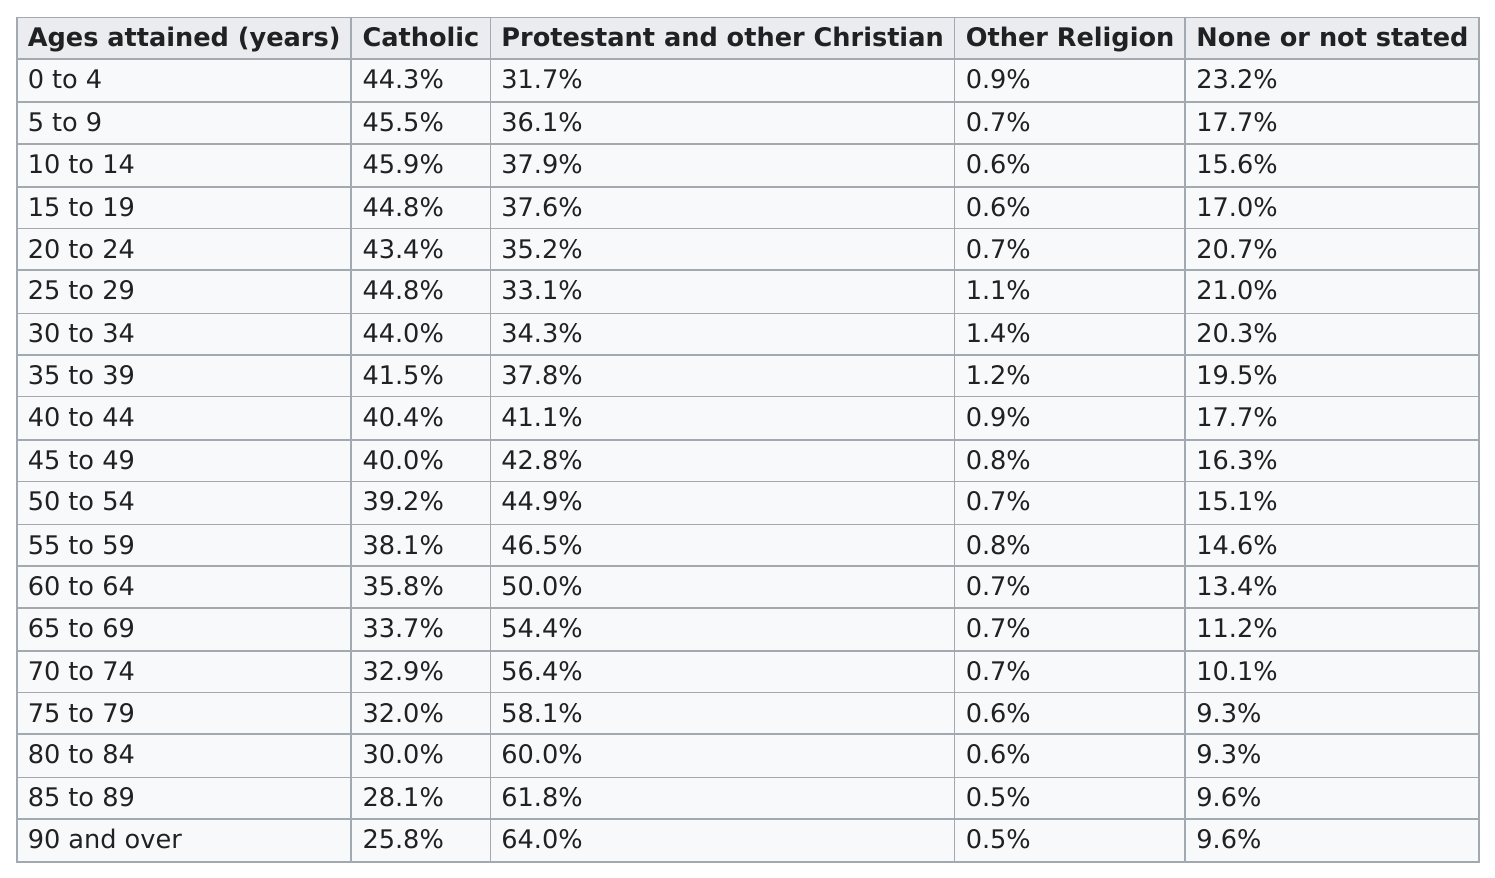List a handful of essential elements in this visual. The age range of 90 and over had the highest number of protestants and other Christians. According to data, the age range of 30 to 34 features the largest percentage of individuals who have no stated religion. Out of the age range of 10 to 14, the Catholic population comprised over 45.6% of the total population in that age range. According to the provided information, the average percentage of Catholics between the age ranges of 5-9 and 10-14 is 45.7%. The percentage of other religions among people aged 30-34 was the largest among all age groups. 